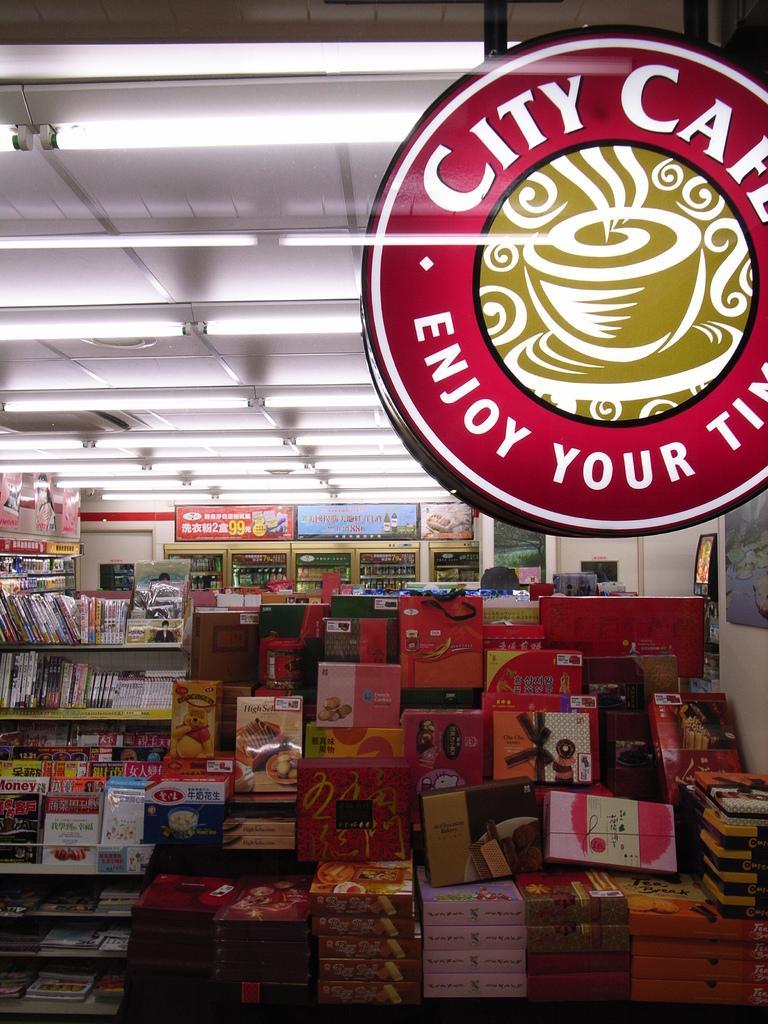Could you give a brief overview of what you see in this image? This image looks like it is clicked in a supermarket. In the front, there are many things kept in the racks. At the top, there is a roof along with the lights. 